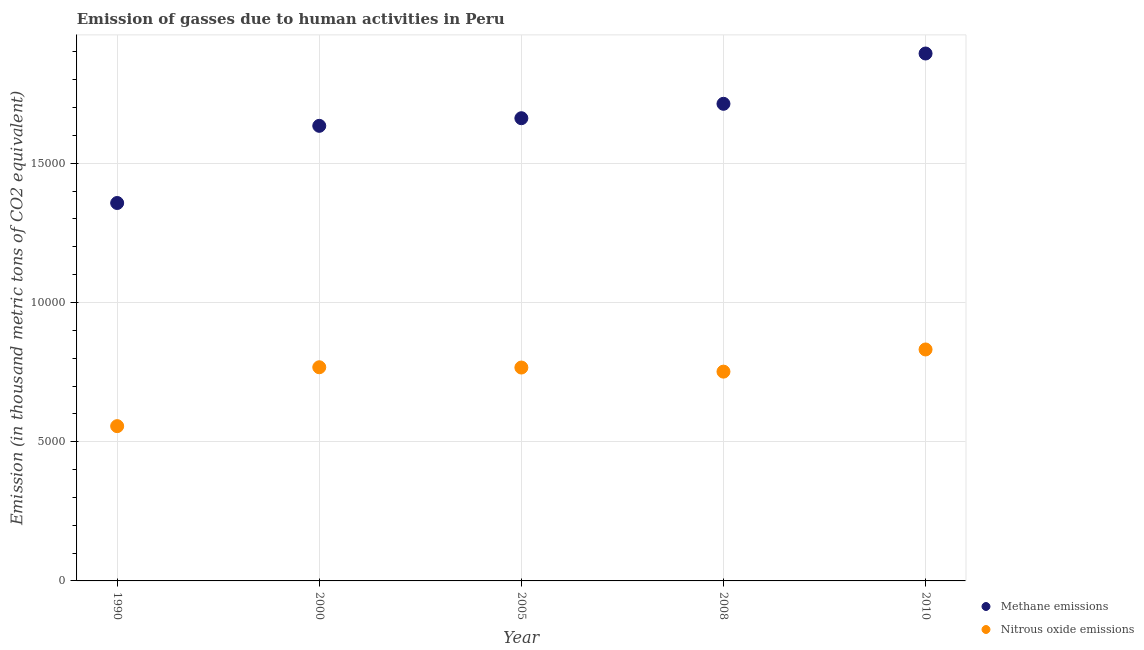Is the number of dotlines equal to the number of legend labels?
Offer a very short reply. Yes. What is the amount of methane emissions in 2000?
Your response must be concise. 1.63e+04. Across all years, what is the maximum amount of methane emissions?
Give a very brief answer. 1.89e+04. Across all years, what is the minimum amount of methane emissions?
Keep it short and to the point. 1.36e+04. In which year was the amount of nitrous oxide emissions minimum?
Your response must be concise. 1990. What is the total amount of nitrous oxide emissions in the graph?
Give a very brief answer. 3.67e+04. What is the difference between the amount of methane emissions in 2008 and that in 2010?
Your response must be concise. -1806.5. What is the difference between the amount of nitrous oxide emissions in 2000 and the amount of methane emissions in 2008?
Offer a terse response. -9462.5. What is the average amount of methane emissions per year?
Offer a very short reply. 1.65e+04. In the year 2005, what is the difference between the amount of methane emissions and amount of nitrous oxide emissions?
Your answer should be very brief. 8954.8. In how many years, is the amount of methane emissions greater than 16000 thousand metric tons?
Your answer should be compact. 4. What is the ratio of the amount of nitrous oxide emissions in 2000 to that in 2010?
Give a very brief answer. 0.92. Is the difference between the amount of methane emissions in 2008 and 2010 greater than the difference between the amount of nitrous oxide emissions in 2008 and 2010?
Offer a very short reply. No. What is the difference between the highest and the second highest amount of methane emissions?
Provide a succinct answer. 1806.5. What is the difference between the highest and the lowest amount of methane emissions?
Make the answer very short. 5369.2. Is the sum of the amount of nitrous oxide emissions in 1990 and 2010 greater than the maximum amount of methane emissions across all years?
Keep it short and to the point. No. Is the amount of nitrous oxide emissions strictly greater than the amount of methane emissions over the years?
Ensure brevity in your answer.  No. Is the amount of nitrous oxide emissions strictly less than the amount of methane emissions over the years?
Make the answer very short. Yes. Are the values on the major ticks of Y-axis written in scientific E-notation?
Your answer should be compact. No. Does the graph contain grids?
Provide a succinct answer. Yes. Where does the legend appear in the graph?
Give a very brief answer. Bottom right. How many legend labels are there?
Ensure brevity in your answer.  2. What is the title of the graph?
Ensure brevity in your answer.  Emission of gasses due to human activities in Peru. What is the label or title of the X-axis?
Provide a succinct answer. Year. What is the label or title of the Y-axis?
Your answer should be compact. Emission (in thousand metric tons of CO2 equivalent). What is the Emission (in thousand metric tons of CO2 equivalent) in Methane emissions in 1990?
Offer a very short reply. 1.36e+04. What is the Emission (in thousand metric tons of CO2 equivalent) of Nitrous oxide emissions in 1990?
Provide a short and direct response. 5559.3. What is the Emission (in thousand metric tons of CO2 equivalent) of Methane emissions in 2000?
Your answer should be compact. 1.63e+04. What is the Emission (in thousand metric tons of CO2 equivalent) in Nitrous oxide emissions in 2000?
Give a very brief answer. 7673.9. What is the Emission (in thousand metric tons of CO2 equivalent) in Methane emissions in 2005?
Offer a very short reply. 1.66e+04. What is the Emission (in thousand metric tons of CO2 equivalent) of Nitrous oxide emissions in 2005?
Provide a succinct answer. 7664.2. What is the Emission (in thousand metric tons of CO2 equivalent) of Methane emissions in 2008?
Your answer should be compact. 1.71e+04. What is the Emission (in thousand metric tons of CO2 equivalent) in Nitrous oxide emissions in 2008?
Keep it short and to the point. 7516.8. What is the Emission (in thousand metric tons of CO2 equivalent) in Methane emissions in 2010?
Make the answer very short. 1.89e+04. What is the Emission (in thousand metric tons of CO2 equivalent) of Nitrous oxide emissions in 2010?
Your answer should be compact. 8313. Across all years, what is the maximum Emission (in thousand metric tons of CO2 equivalent) of Methane emissions?
Your answer should be compact. 1.89e+04. Across all years, what is the maximum Emission (in thousand metric tons of CO2 equivalent) of Nitrous oxide emissions?
Keep it short and to the point. 8313. Across all years, what is the minimum Emission (in thousand metric tons of CO2 equivalent) of Methane emissions?
Provide a short and direct response. 1.36e+04. Across all years, what is the minimum Emission (in thousand metric tons of CO2 equivalent) of Nitrous oxide emissions?
Make the answer very short. 5559.3. What is the total Emission (in thousand metric tons of CO2 equivalent) of Methane emissions in the graph?
Your answer should be compact. 8.26e+04. What is the total Emission (in thousand metric tons of CO2 equivalent) of Nitrous oxide emissions in the graph?
Your answer should be very brief. 3.67e+04. What is the difference between the Emission (in thousand metric tons of CO2 equivalent) in Methane emissions in 1990 and that in 2000?
Your answer should be very brief. -2771.4. What is the difference between the Emission (in thousand metric tons of CO2 equivalent) of Nitrous oxide emissions in 1990 and that in 2000?
Offer a very short reply. -2114.6. What is the difference between the Emission (in thousand metric tons of CO2 equivalent) of Methane emissions in 1990 and that in 2005?
Your answer should be compact. -3045.3. What is the difference between the Emission (in thousand metric tons of CO2 equivalent) of Nitrous oxide emissions in 1990 and that in 2005?
Offer a terse response. -2104.9. What is the difference between the Emission (in thousand metric tons of CO2 equivalent) in Methane emissions in 1990 and that in 2008?
Make the answer very short. -3562.7. What is the difference between the Emission (in thousand metric tons of CO2 equivalent) of Nitrous oxide emissions in 1990 and that in 2008?
Your answer should be very brief. -1957.5. What is the difference between the Emission (in thousand metric tons of CO2 equivalent) of Methane emissions in 1990 and that in 2010?
Keep it short and to the point. -5369.2. What is the difference between the Emission (in thousand metric tons of CO2 equivalent) in Nitrous oxide emissions in 1990 and that in 2010?
Make the answer very short. -2753.7. What is the difference between the Emission (in thousand metric tons of CO2 equivalent) of Methane emissions in 2000 and that in 2005?
Make the answer very short. -273.9. What is the difference between the Emission (in thousand metric tons of CO2 equivalent) in Nitrous oxide emissions in 2000 and that in 2005?
Your response must be concise. 9.7. What is the difference between the Emission (in thousand metric tons of CO2 equivalent) of Methane emissions in 2000 and that in 2008?
Your answer should be compact. -791.3. What is the difference between the Emission (in thousand metric tons of CO2 equivalent) of Nitrous oxide emissions in 2000 and that in 2008?
Ensure brevity in your answer.  157.1. What is the difference between the Emission (in thousand metric tons of CO2 equivalent) in Methane emissions in 2000 and that in 2010?
Offer a terse response. -2597.8. What is the difference between the Emission (in thousand metric tons of CO2 equivalent) in Nitrous oxide emissions in 2000 and that in 2010?
Offer a terse response. -639.1. What is the difference between the Emission (in thousand metric tons of CO2 equivalent) in Methane emissions in 2005 and that in 2008?
Give a very brief answer. -517.4. What is the difference between the Emission (in thousand metric tons of CO2 equivalent) in Nitrous oxide emissions in 2005 and that in 2008?
Your response must be concise. 147.4. What is the difference between the Emission (in thousand metric tons of CO2 equivalent) of Methane emissions in 2005 and that in 2010?
Give a very brief answer. -2323.9. What is the difference between the Emission (in thousand metric tons of CO2 equivalent) of Nitrous oxide emissions in 2005 and that in 2010?
Provide a short and direct response. -648.8. What is the difference between the Emission (in thousand metric tons of CO2 equivalent) of Methane emissions in 2008 and that in 2010?
Give a very brief answer. -1806.5. What is the difference between the Emission (in thousand metric tons of CO2 equivalent) in Nitrous oxide emissions in 2008 and that in 2010?
Make the answer very short. -796.2. What is the difference between the Emission (in thousand metric tons of CO2 equivalent) in Methane emissions in 1990 and the Emission (in thousand metric tons of CO2 equivalent) in Nitrous oxide emissions in 2000?
Make the answer very short. 5899.8. What is the difference between the Emission (in thousand metric tons of CO2 equivalent) in Methane emissions in 1990 and the Emission (in thousand metric tons of CO2 equivalent) in Nitrous oxide emissions in 2005?
Offer a very short reply. 5909.5. What is the difference between the Emission (in thousand metric tons of CO2 equivalent) of Methane emissions in 1990 and the Emission (in thousand metric tons of CO2 equivalent) of Nitrous oxide emissions in 2008?
Provide a succinct answer. 6056.9. What is the difference between the Emission (in thousand metric tons of CO2 equivalent) of Methane emissions in 1990 and the Emission (in thousand metric tons of CO2 equivalent) of Nitrous oxide emissions in 2010?
Provide a succinct answer. 5260.7. What is the difference between the Emission (in thousand metric tons of CO2 equivalent) in Methane emissions in 2000 and the Emission (in thousand metric tons of CO2 equivalent) in Nitrous oxide emissions in 2005?
Offer a very short reply. 8680.9. What is the difference between the Emission (in thousand metric tons of CO2 equivalent) of Methane emissions in 2000 and the Emission (in thousand metric tons of CO2 equivalent) of Nitrous oxide emissions in 2008?
Your answer should be compact. 8828.3. What is the difference between the Emission (in thousand metric tons of CO2 equivalent) of Methane emissions in 2000 and the Emission (in thousand metric tons of CO2 equivalent) of Nitrous oxide emissions in 2010?
Provide a short and direct response. 8032.1. What is the difference between the Emission (in thousand metric tons of CO2 equivalent) of Methane emissions in 2005 and the Emission (in thousand metric tons of CO2 equivalent) of Nitrous oxide emissions in 2008?
Offer a terse response. 9102.2. What is the difference between the Emission (in thousand metric tons of CO2 equivalent) in Methane emissions in 2005 and the Emission (in thousand metric tons of CO2 equivalent) in Nitrous oxide emissions in 2010?
Your response must be concise. 8306. What is the difference between the Emission (in thousand metric tons of CO2 equivalent) in Methane emissions in 2008 and the Emission (in thousand metric tons of CO2 equivalent) in Nitrous oxide emissions in 2010?
Make the answer very short. 8823.4. What is the average Emission (in thousand metric tons of CO2 equivalent) in Methane emissions per year?
Your response must be concise. 1.65e+04. What is the average Emission (in thousand metric tons of CO2 equivalent) in Nitrous oxide emissions per year?
Ensure brevity in your answer.  7345.44. In the year 1990, what is the difference between the Emission (in thousand metric tons of CO2 equivalent) in Methane emissions and Emission (in thousand metric tons of CO2 equivalent) in Nitrous oxide emissions?
Your response must be concise. 8014.4. In the year 2000, what is the difference between the Emission (in thousand metric tons of CO2 equivalent) of Methane emissions and Emission (in thousand metric tons of CO2 equivalent) of Nitrous oxide emissions?
Ensure brevity in your answer.  8671.2. In the year 2005, what is the difference between the Emission (in thousand metric tons of CO2 equivalent) in Methane emissions and Emission (in thousand metric tons of CO2 equivalent) in Nitrous oxide emissions?
Keep it short and to the point. 8954.8. In the year 2008, what is the difference between the Emission (in thousand metric tons of CO2 equivalent) of Methane emissions and Emission (in thousand metric tons of CO2 equivalent) of Nitrous oxide emissions?
Your answer should be compact. 9619.6. In the year 2010, what is the difference between the Emission (in thousand metric tons of CO2 equivalent) of Methane emissions and Emission (in thousand metric tons of CO2 equivalent) of Nitrous oxide emissions?
Your response must be concise. 1.06e+04. What is the ratio of the Emission (in thousand metric tons of CO2 equivalent) in Methane emissions in 1990 to that in 2000?
Provide a short and direct response. 0.83. What is the ratio of the Emission (in thousand metric tons of CO2 equivalent) of Nitrous oxide emissions in 1990 to that in 2000?
Offer a terse response. 0.72. What is the ratio of the Emission (in thousand metric tons of CO2 equivalent) of Methane emissions in 1990 to that in 2005?
Give a very brief answer. 0.82. What is the ratio of the Emission (in thousand metric tons of CO2 equivalent) in Nitrous oxide emissions in 1990 to that in 2005?
Provide a short and direct response. 0.73. What is the ratio of the Emission (in thousand metric tons of CO2 equivalent) in Methane emissions in 1990 to that in 2008?
Your answer should be compact. 0.79. What is the ratio of the Emission (in thousand metric tons of CO2 equivalent) of Nitrous oxide emissions in 1990 to that in 2008?
Provide a short and direct response. 0.74. What is the ratio of the Emission (in thousand metric tons of CO2 equivalent) of Methane emissions in 1990 to that in 2010?
Your answer should be compact. 0.72. What is the ratio of the Emission (in thousand metric tons of CO2 equivalent) of Nitrous oxide emissions in 1990 to that in 2010?
Your response must be concise. 0.67. What is the ratio of the Emission (in thousand metric tons of CO2 equivalent) in Methane emissions in 2000 to that in 2005?
Your answer should be very brief. 0.98. What is the ratio of the Emission (in thousand metric tons of CO2 equivalent) in Nitrous oxide emissions in 2000 to that in 2005?
Your response must be concise. 1. What is the ratio of the Emission (in thousand metric tons of CO2 equivalent) of Methane emissions in 2000 to that in 2008?
Your answer should be very brief. 0.95. What is the ratio of the Emission (in thousand metric tons of CO2 equivalent) of Nitrous oxide emissions in 2000 to that in 2008?
Offer a very short reply. 1.02. What is the ratio of the Emission (in thousand metric tons of CO2 equivalent) in Methane emissions in 2000 to that in 2010?
Give a very brief answer. 0.86. What is the ratio of the Emission (in thousand metric tons of CO2 equivalent) of Nitrous oxide emissions in 2000 to that in 2010?
Your answer should be very brief. 0.92. What is the ratio of the Emission (in thousand metric tons of CO2 equivalent) in Methane emissions in 2005 to that in 2008?
Provide a short and direct response. 0.97. What is the ratio of the Emission (in thousand metric tons of CO2 equivalent) in Nitrous oxide emissions in 2005 to that in 2008?
Provide a short and direct response. 1.02. What is the ratio of the Emission (in thousand metric tons of CO2 equivalent) in Methane emissions in 2005 to that in 2010?
Provide a short and direct response. 0.88. What is the ratio of the Emission (in thousand metric tons of CO2 equivalent) of Nitrous oxide emissions in 2005 to that in 2010?
Ensure brevity in your answer.  0.92. What is the ratio of the Emission (in thousand metric tons of CO2 equivalent) of Methane emissions in 2008 to that in 2010?
Give a very brief answer. 0.9. What is the ratio of the Emission (in thousand metric tons of CO2 equivalent) of Nitrous oxide emissions in 2008 to that in 2010?
Keep it short and to the point. 0.9. What is the difference between the highest and the second highest Emission (in thousand metric tons of CO2 equivalent) in Methane emissions?
Your response must be concise. 1806.5. What is the difference between the highest and the second highest Emission (in thousand metric tons of CO2 equivalent) of Nitrous oxide emissions?
Provide a succinct answer. 639.1. What is the difference between the highest and the lowest Emission (in thousand metric tons of CO2 equivalent) of Methane emissions?
Your answer should be very brief. 5369.2. What is the difference between the highest and the lowest Emission (in thousand metric tons of CO2 equivalent) in Nitrous oxide emissions?
Make the answer very short. 2753.7. 